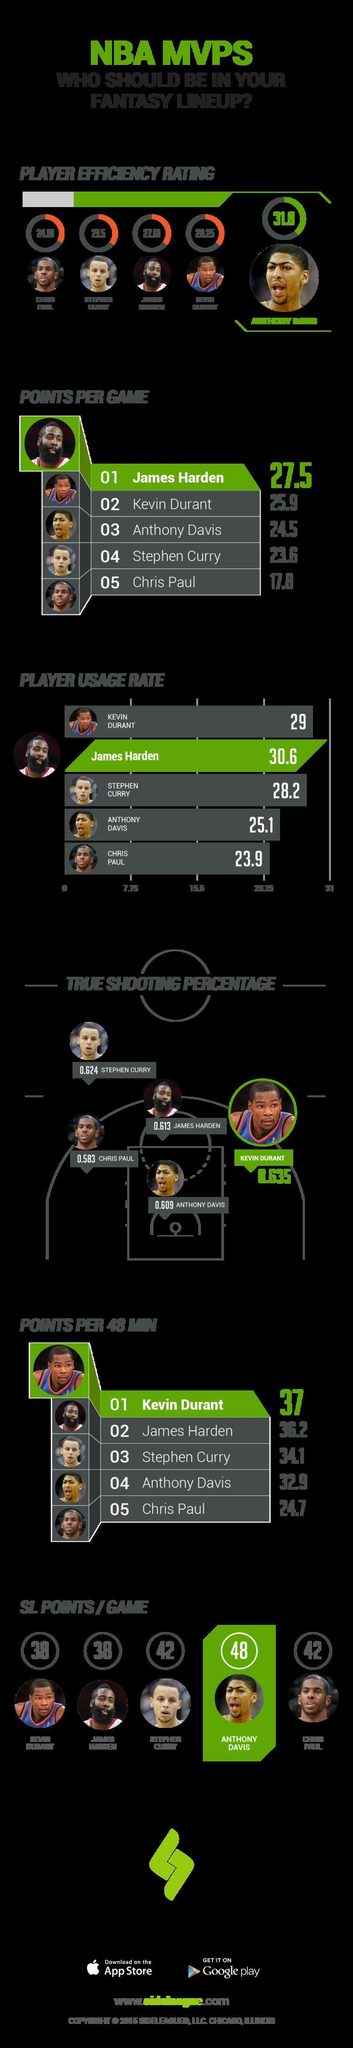Which NBA player in the infographic has SL Points/Game above 45?
Answer the question with a short phrase. Anthony Davis How many players shown in the infographic have SL Points/game 42? 2 Which player shown in the infographic has Points Per Game below 20? Chris Paul Which NBA player shown in the infographic has the second highest True shooting percentage? Stephen Curry Which of the 5 NBA players shown has the second lowest Player Usage Rate? Anthony Davis Which of the 5 NBA players shown has the second lowest Points per Game? Stephen Curry Which player has the second highest player usage rate? Kevin Durant Which NBA player shown in the infographic has Player Usage Rate above 30? James Harden Which NBA player shown in the infographic has the third highest True shooting percentage? James Harden Which NBA player shown in the infographic has Points per 48 min lower than 25? Chris Paul 